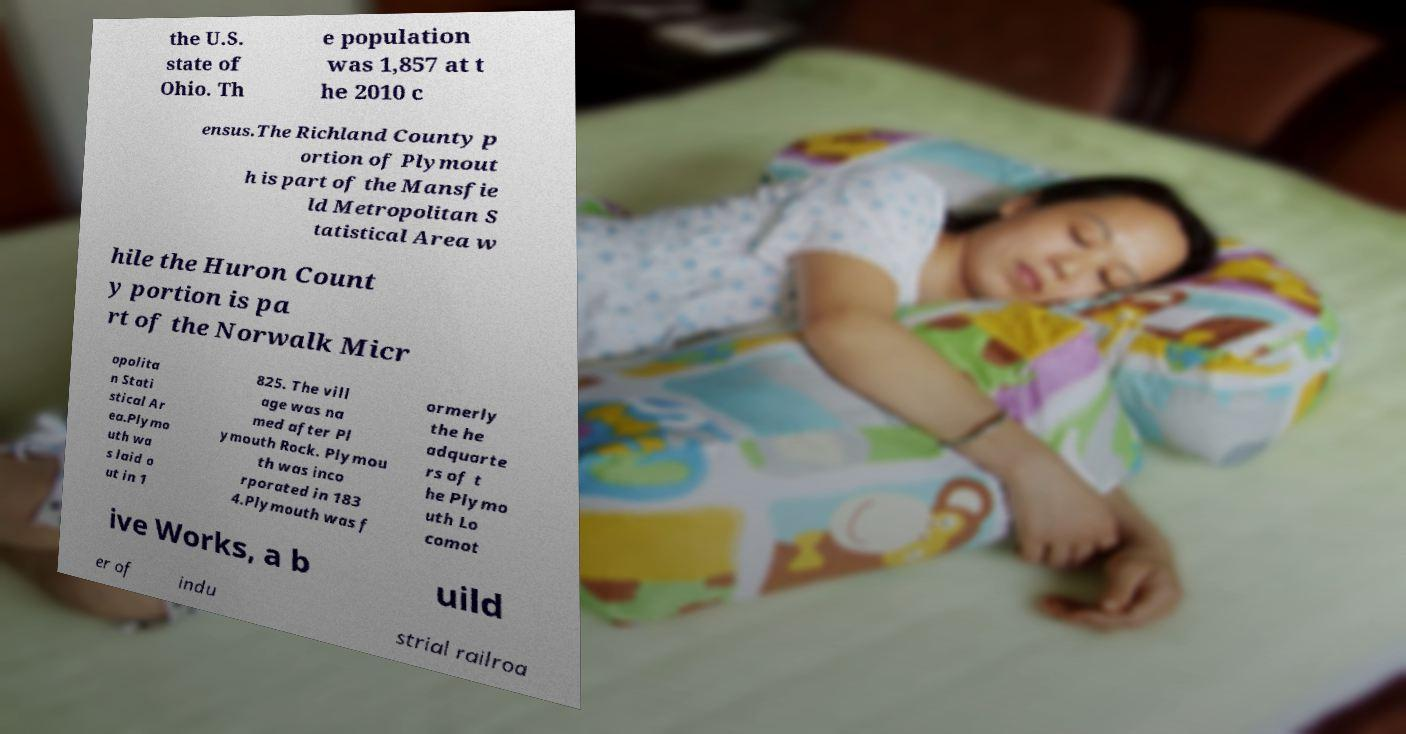Could you extract and type out the text from this image? the U.S. state of Ohio. Th e population was 1,857 at t he 2010 c ensus.The Richland County p ortion of Plymout h is part of the Mansfie ld Metropolitan S tatistical Area w hile the Huron Count y portion is pa rt of the Norwalk Micr opolita n Stati stical Ar ea.Plymo uth wa s laid o ut in 1 825. The vill age was na med after Pl ymouth Rock. Plymou th was inco rporated in 183 4.Plymouth was f ormerly the he adquarte rs of t he Plymo uth Lo comot ive Works, a b uild er of indu strial railroa 